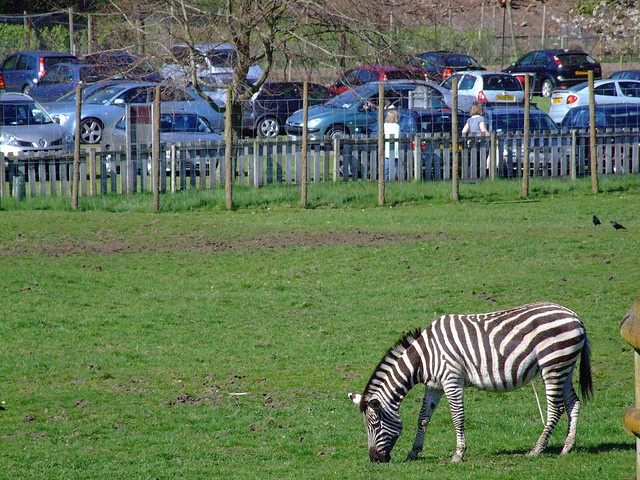Describe the objects in this image and their specific colors. I can see zebra in black, gray, white, and darkgray tones, car in black, gray, navy, and blue tones, car in black and gray tones, car in black and gray tones, and car in black, gray, and darkgray tones in this image. 